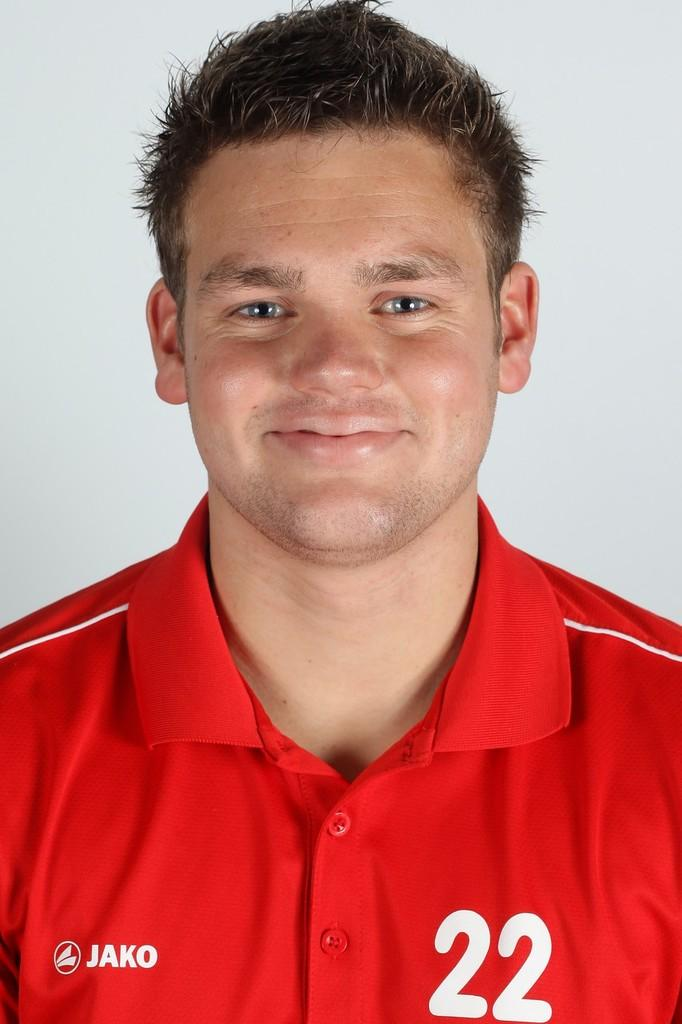<image>
Write a terse but informative summary of the picture. A smiling man wears a red JAKO shirt that bears the number 22 on the front. 